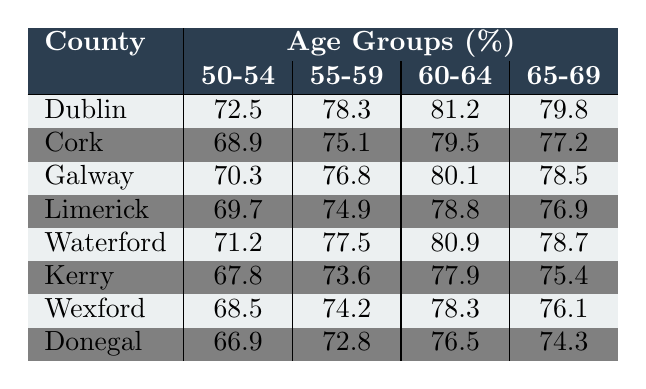What is the breast cancer screening rate for women aged 50-54 in Dublin? According to the table, the screening rate for women aged 50-54 in Dublin is listed specifically under that age group. It shows a percentage of 72.5%.
Answer: 72.5% Which county has the highest breast cancer screening rate for women aged 60-64? By looking at the rates for the age group 60-64 across all counties, Dublin has the highest rate, which is 81.2%.
Answer: Dublin What are the breast cancer screening rates for women aged 65-69 in Kerry and Donegal? The rates for women aged 65-69 in both counties can be found in the respective rows of the table. For Kerry, it is 75.4%, and for Donegal, it is 74.3%.
Answer: Kerry: 75.4%, Donegal: 74.3% What is the average breast cancer screening rate for women aged 55-59 across all counties? To find the average, I will add the percentages for the age group 55-59 across the counties: (78.3 + 75.1 + 76.8 + 74.9 + 77.5 + 73.6 + 74.2 + 72.8) = 605.2. There are 8 counties, so the average is 605.2 / 8 = 75.65%.
Answer: 75.65% Is the breast cancer screening rate for women aged 50-54 in Galway higher than that in Kerry? In the table, the screening rate for women aged 50-54 in Galway is 70.3%, whereas in Kerry it is 67.8%. Since 70.3% is greater than 67.8%, the statement is true.
Answer: Yes Which county has the lowest breast cancer screening rate for women aged 60-64? The table indicates that Donegal has the lowest breast cancer screening rate among women aged 60-64, with a rate of 76.5%.
Answer: Donegal What is the difference in breast cancer screening rates between the ages of 55-59 and 65-69 for Cork? For Cork, the screening rate for 55-59 is 75.1% and for 65-69 it is 77.2%. The difference can be calculated by subtracting: 77.2 - 75.1 = 2.1%.
Answer: 2.1% What is the median breast cancer screening rate for the age group 60-64 across all counties? The rates for the age group 60-64 are: 81.2 (Dublin), 79.5 (Cork), 80.1 (Galway), 78.8 (Limerick), 80.9 (Waterford), 77.9 (Kerry), 78.3 (Wexford), 76.5 (Donegal). Sorting these values gives: 76.5, 77.9, 78.3, 78.8, 79.5, 80.1, 80.9, 81.2. The median is the average of the two middle values (78.8 and 79.5): (78.8 + 79.5) / 2 = 79.15%.
Answer: 79.15% Is the breast cancer screening rate for women aged 65-69 higher in Limerick than in Waterford? In the table, Limerick's rate is 76.9% and Waterford's rate is 78.7%. Since 76.9% is less than 78.7%, the statement is false.
Answer: No 